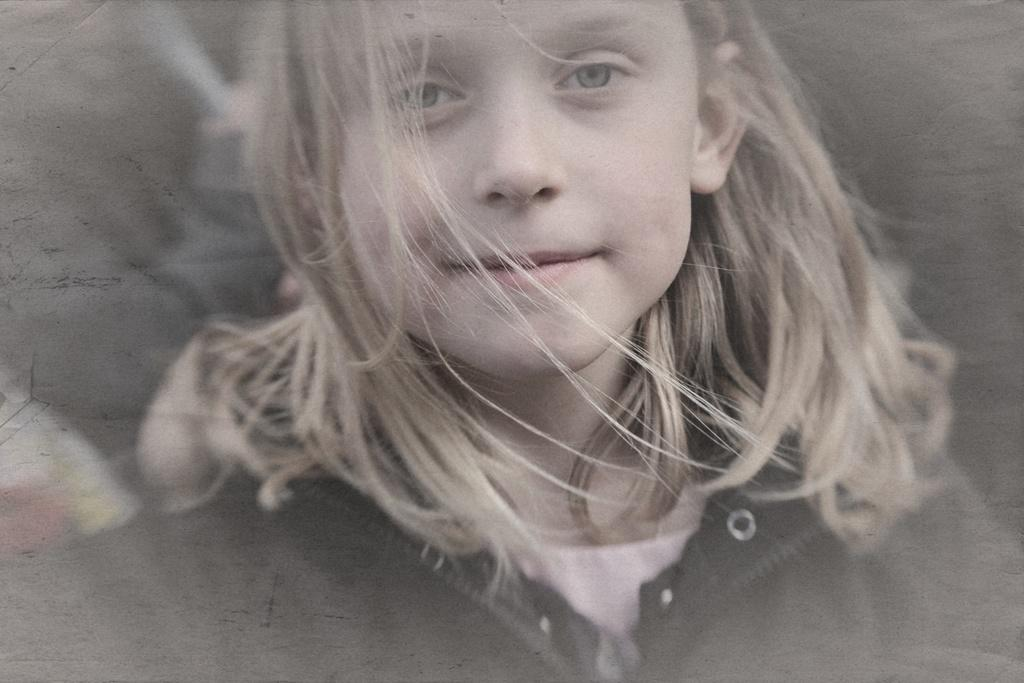What is the main subject of the image? There is a child in the image. What is the child wearing? The child is wearing a black jacket. How is the child's expression in the image? The child is smiling. Can you describe the quality of the image? The image is slightly blurred in this part. What time of day is it in the image, and is the child crying? The time of day is not mentioned in the image, and there is no indication that the child is crying; they are smiling. 